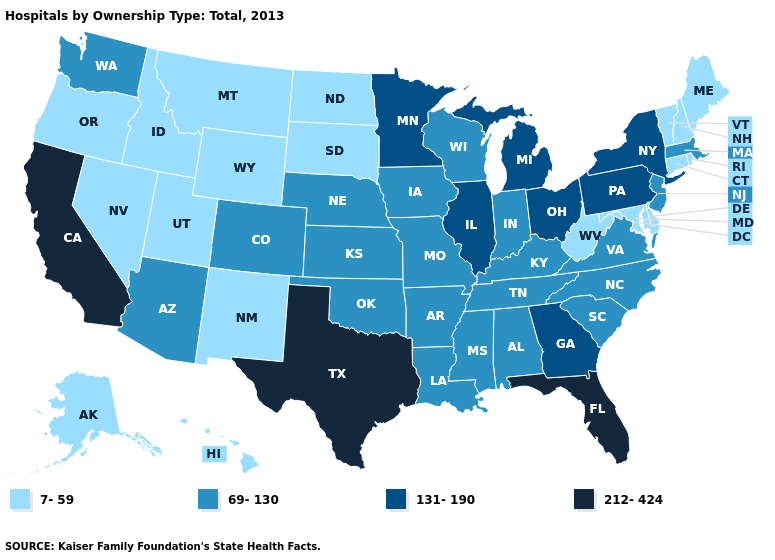What is the highest value in the USA?
Answer briefly. 212-424. What is the value of North Carolina?
Answer briefly. 69-130. Name the states that have a value in the range 7-59?
Give a very brief answer. Alaska, Connecticut, Delaware, Hawaii, Idaho, Maine, Maryland, Montana, Nevada, New Hampshire, New Mexico, North Dakota, Oregon, Rhode Island, South Dakota, Utah, Vermont, West Virginia, Wyoming. Name the states that have a value in the range 212-424?
Answer briefly. California, Florida, Texas. What is the value of Nebraska?
Concise answer only. 69-130. Name the states that have a value in the range 7-59?
Write a very short answer. Alaska, Connecticut, Delaware, Hawaii, Idaho, Maine, Maryland, Montana, Nevada, New Hampshire, New Mexico, North Dakota, Oregon, Rhode Island, South Dakota, Utah, Vermont, West Virginia, Wyoming. Name the states that have a value in the range 131-190?
Write a very short answer. Georgia, Illinois, Michigan, Minnesota, New York, Ohio, Pennsylvania. What is the value of West Virginia?
Keep it brief. 7-59. Does Illinois have the same value as Indiana?
Write a very short answer. No. Does Oregon have the highest value in the West?
Short answer required. No. What is the value of Indiana?
Give a very brief answer. 69-130. What is the highest value in the MidWest ?
Short answer required. 131-190. Does Wyoming have the same value as Alaska?
Be succinct. Yes. Does the map have missing data?
Short answer required. No. 